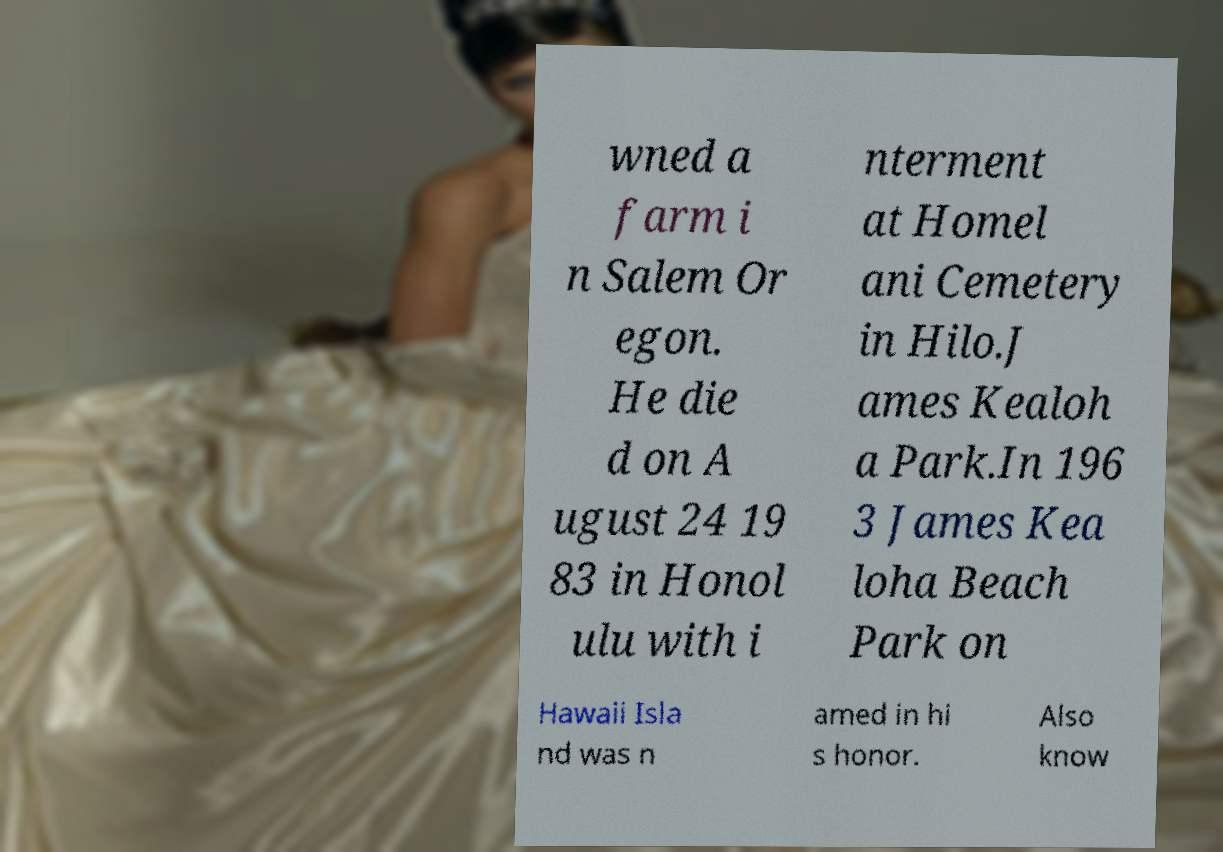I need the written content from this picture converted into text. Can you do that? wned a farm i n Salem Or egon. He die d on A ugust 24 19 83 in Honol ulu with i nterment at Homel ani Cemetery in Hilo.J ames Kealoh a Park.In 196 3 James Kea loha Beach Park on Hawaii Isla nd was n amed in hi s honor. Also know 